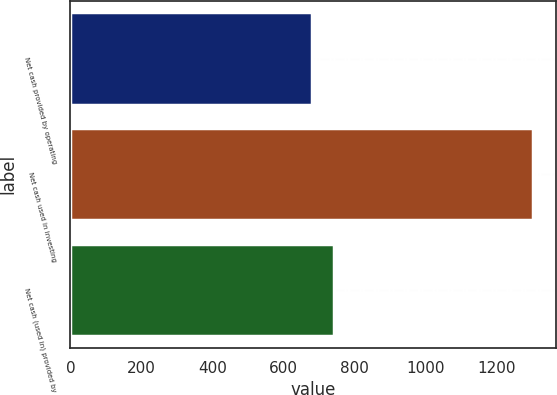Convert chart to OTSL. <chart><loc_0><loc_0><loc_500><loc_500><bar_chart><fcel>Net cash provided by operating<fcel>Net cash used in investing<fcel>Net cash (used in) provided by<nl><fcel>681.5<fcel>1303.4<fcel>743.69<nl></chart> 